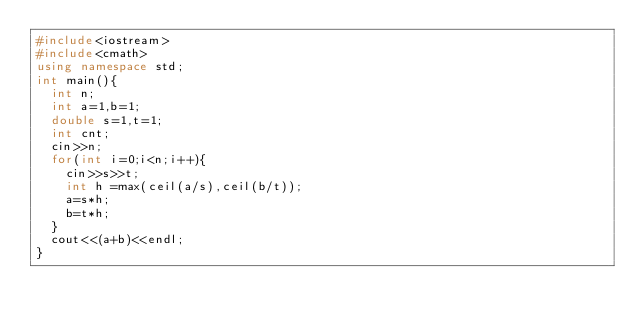Convert code to text. <code><loc_0><loc_0><loc_500><loc_500><_C++_>#include<iostream>
#include<cmath>
using namespace std;
int main(){
  int n;
  int a=1,b=1;
  double s=1,t=1;
  int cnt;
  cin>>n;
  for(int i=0;i<n;i++){
    cin>>s>>t;
    int h =max(ceil(a/s),ceil(b/t));
    a=s*h;
    b=t*h;
  }
  cout<<(a+b)<<endl;
}</code> 